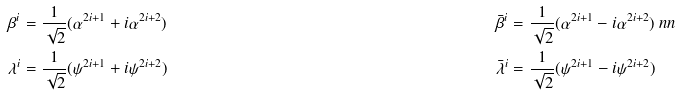Convert formula to latex. <formula><loc_0><loc_0><loc_500><loc_500>\beta ^ { i } & = \frac { 1 } { \sqrt { 2 } } ( \alpha ^ { 2 i + 1 } + i \alpha ^ { 2 i + 2 } ) & \bar { \beta } ^ { i } & = \frac { 1 } { \sqrt { 2 } } ( \alpha ^ { 2 i + 1 } - i \alpha ^ { 2 i + 2 } ) \ n n \\ \lambda ^ { i } & = \frac { 1 } { \sqrt { 2 } } ( \psi ^ { 2 i + 1 } + i \psi ^ { 2 i + 2 } ) & \bar { \lambda } ^ { i } & = \frac { 1 } { \sqrt { 2 } } ( \psi ^ { 2 i + 1 } - i \psi ^ { 2 i + 2 } )</formula> 